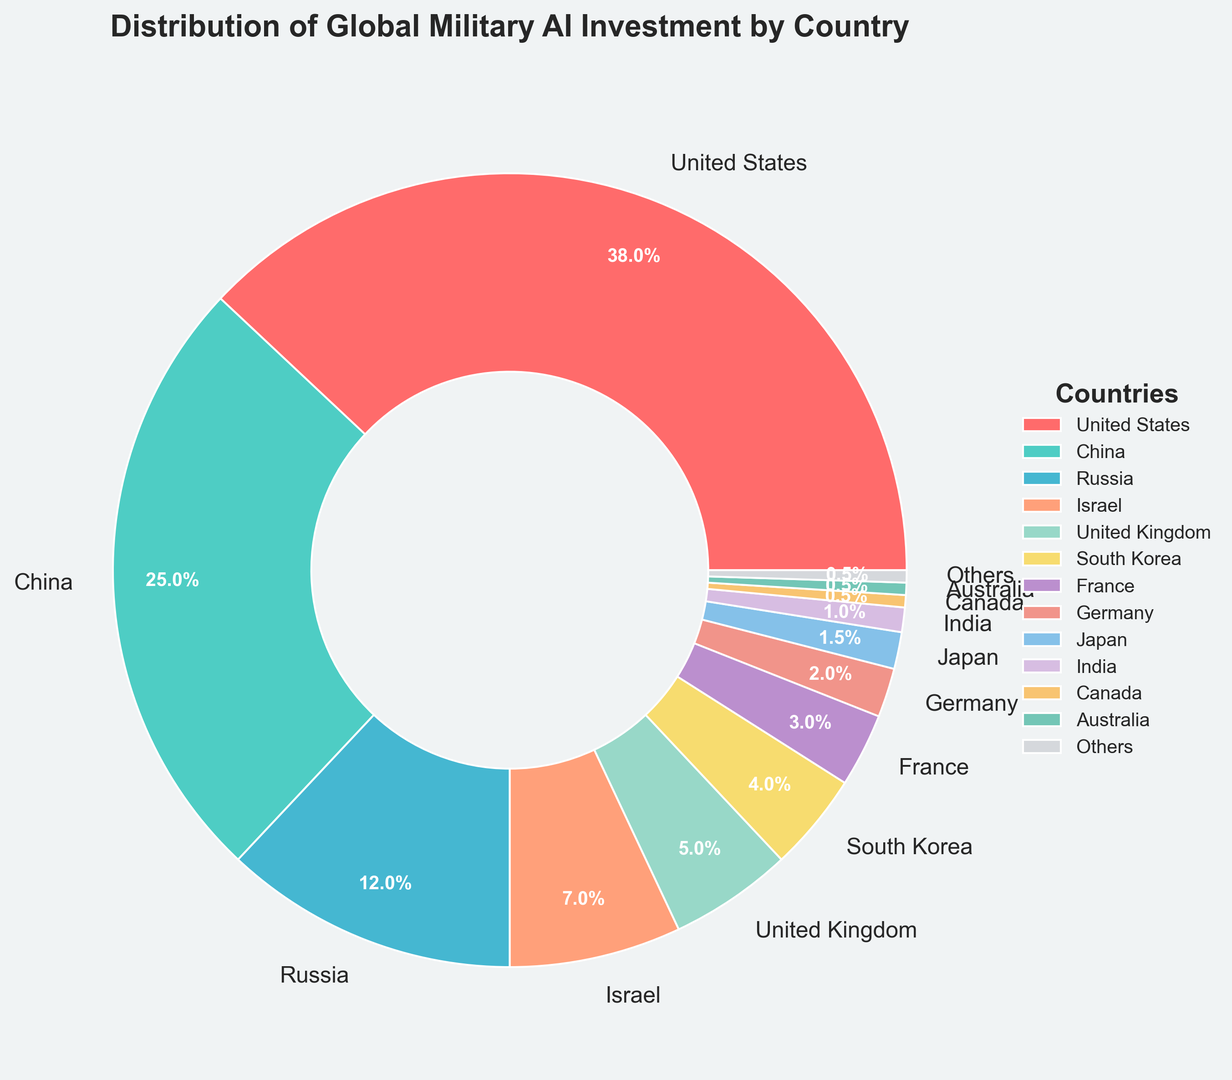What percentage of global military AI investment is attributed to the top three countries? The percentages for the United States, China, and Russia are 38%, 25%, and 12% respectively. Summing these values: 38 + 25 + 12 = 75%. Therefore, the top three countries together account for 75% of the global military AI investment.
Answer: 75% Which country has the second highest military AI investment? The figure shows that China has the second highest percentage of 25%, following the United States.
Answer: China Is the sum of the investments of India, Canada, and Australia greater than that of Germany? India, Canada, and Australia each have 0.5% investments, summing up to 1% + 0.5% + 0.5% = 2%. Germany has 2% investment. Thus, the sum of the investments from India, Canada, and Australia is equal to that of Germany.
Answer: No Which countries have an investment of less than 5%? By examining the chart, the countries with less than 5% investment are South Korea (4%), France (3%), Germany (2%), Japan (1.5%), India (1%), Canada (0.5%), Australia (0.5%), and Others (0.5%).
Answer: South Korea, France, Germany, Japan, India, Canada, Australia, Others Is the investment of the United Kingdom greater than or equal to the combined investments of Israel and South Korea? The United Kingdom has 5% investment. Israel has 7% and South Korea has 4%, summing up to 7 + 4 = 11%. Therefore, the United Kingdom's investment is not greater than or equal to the combined investments of Israel and South Korea.
Answer: No Which segment is smaller in size, Germany's or France's? In the figure, Germany has a 2% share and France has a 3% share. Therefore, Germany's segment is smaller than France's.
Answer: Germany's What is the total percentage of global military AI investment attributed to countries with investments of 1% or lower? Examining the figure, the countries with 1% or lower are Japan (1.5%), India (1%), Canada (0.5%), Australia (0.5%), and Others (0.5%). Their total is 1.5% + 1% + 0.5% + 0.5% + 0.5% = 4%.
Answer: 4% Compare the investments of Russia and Israel. Which country invests more and by how much? The figure shows that Russia has 12% investment while Israel has 7%. The difference is 12 - 7 = 5%. Therefore, Russia invests 5% more than Israel.
Answer: Russia by 5% Among all countries listed, which one has the smallest investment, and what is the percentage? According to the figure, Canada, Australia, and Others each have the smallest investment at 0.5%.
Answer: Canada, Australia, Others What is the average investment percentage of South Korea, France, and Germany? The investment percentages for South Korea, France, and Germany are 4%, 3%, and 2% respectively. The average is calculated as (4 + 3 + 2) / 3 = 9 / 3 = 3%.
Answer: 3% 